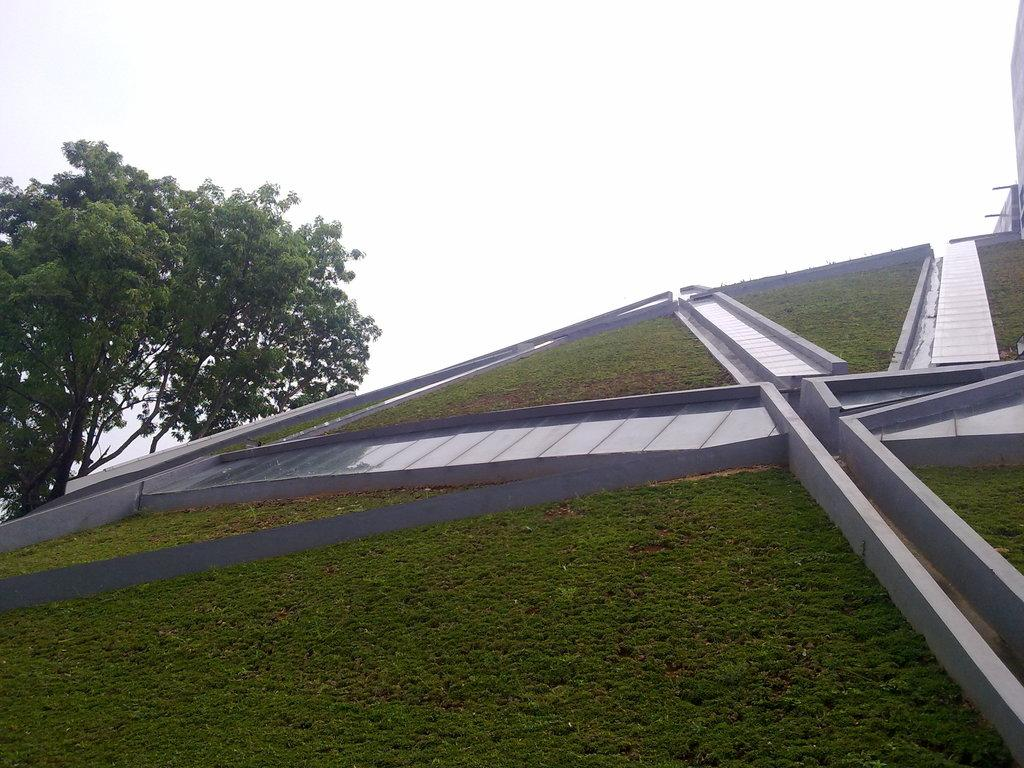What type of structure is depicted in the image? There is an architecture in the image. Where is the tree located in the image? The tree is on the left side of the image. What can be seen in the background of the image? The sky is visible in the background of the image. What type of corn can be seen growing on the branch in the image? There is no corn or branch present in the image. What time is indicated by the clock in the image? There is no clock present in the image. 